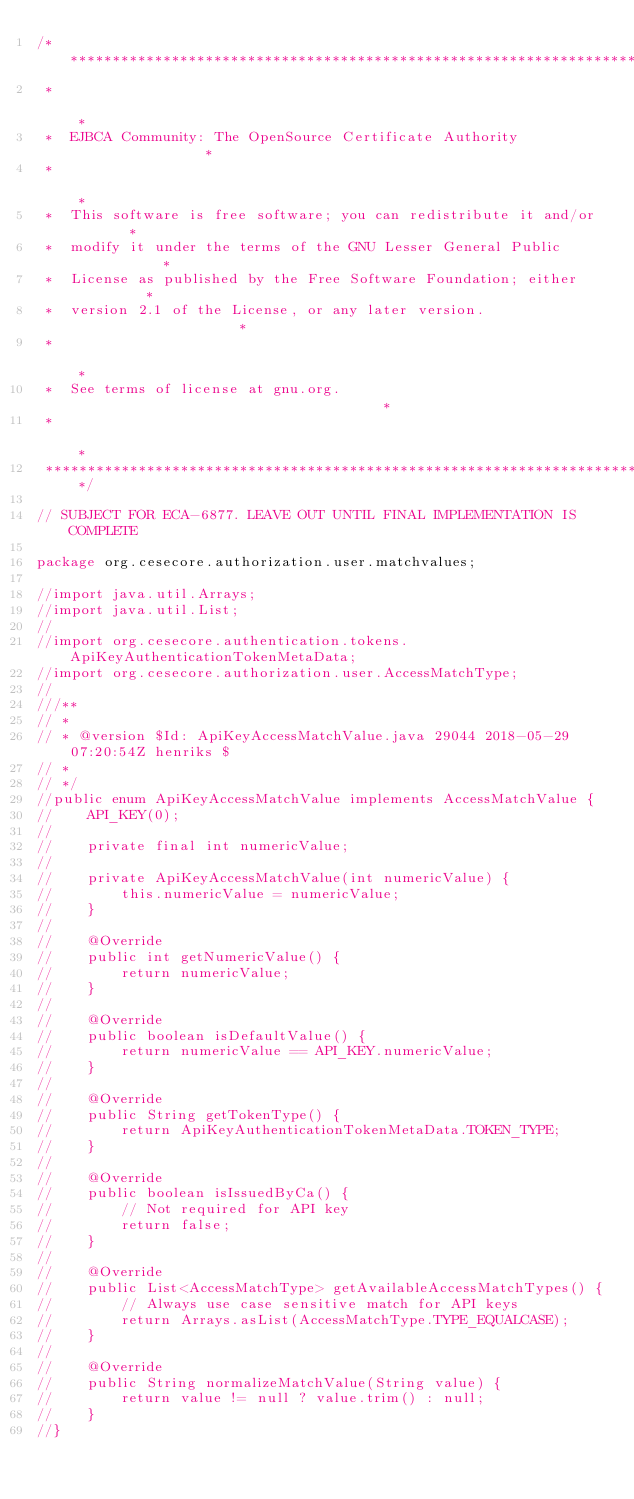<code> <loc_0><loc_0><loc_500><loc_500><_Java_>/*************************************************************************
 *                                                                       *
 *  EJBCA Community: The OpenSource Certificate Authority                *
 *                                                                       *
 *  This software is free software; you can redistribute it and/or       *
 *  modify it under the terms of the GNU Lesser General Public           *
 *  License as published by the Free Software Foundation; either         *
 *  version 2.1 of the License, or any later version.                    *
 *                                                                       *
 *  See terms of license at gnu.org.                                     *
 *                                                                       *
 *************************************************************************/

// SUBJECT FOR ECA-6877. LEAVE OUT UNTIL FINAL IMPLEMENTATION IS COMPLETE

package org.cesecore.authorization.user.matchvalues;

//import java.util.Arrays;
//import java.util.List;
//
//import org.cesecore.authentication.tokens.ApiKeyAuthenticationTokenMetaData;
//import org.cesecore.authorization.user.AccessMatchType;
//
///**
// * 
// * @version $Id: ApiKeyAccessMatchValue.java 29044 2018-05-29 07:20:54Z henriks $
// *
// */
//public enum ApiKeyAccessMatchValue implements AccessMatchValue {
//    API_KEY(0);
//
//    private final int numericValue;
//    
//    private ApiKeyAccessMatchValue(int numericValue) {
//        this.numericValue = numericValue;
//    }
//    
//    @Override
//    public int getNumericValue() {
//        return numericValue;
//    }
//
//    @Override
//    public boolean isDefaultValue() {
//        return numericValue == API_KEY.numericValue;
//    }
//
//    @Override
//    public String getTokenType() {
//        return ApiKeyAuthenticationTokenMetaData.TOKEN_TYPE;
//    }
//
//    @Override
//    public boolean isIssuedByCa() {
//        // Not required for API key
//        return false;
//    }
//
//    @Override
//    public List<AccessMatchType> getAvailableAccessMatchTypes() {
//        // Always use case sensitive match for API keys
//        return Arrays.asList(AccessMatchType.TYPE_EQUALCASE);
//    }
//
//    @Override
//    public String normalizeMatchValue(String value) {
//        return value != null ? value.trim() : null;
//    }
//}</code> 